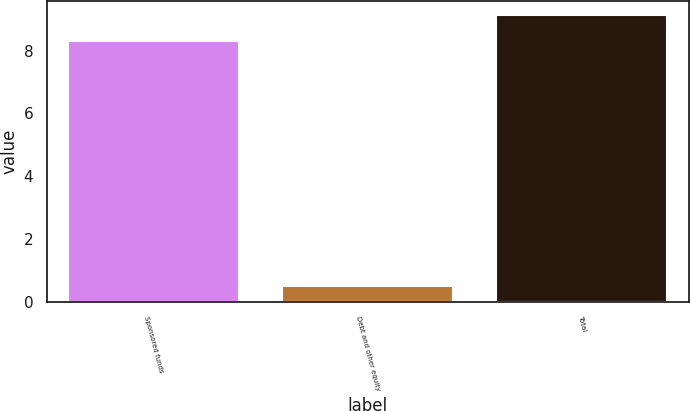<chart> <loc_0><loc_0><loc_500><loc_500><bar_chart><fcel>Sponsored funds<fcel>Debt and other equity<fcel>Total<nl><fcel>8.3<fcel>0.5<fcel>9.13<nl></chart> 